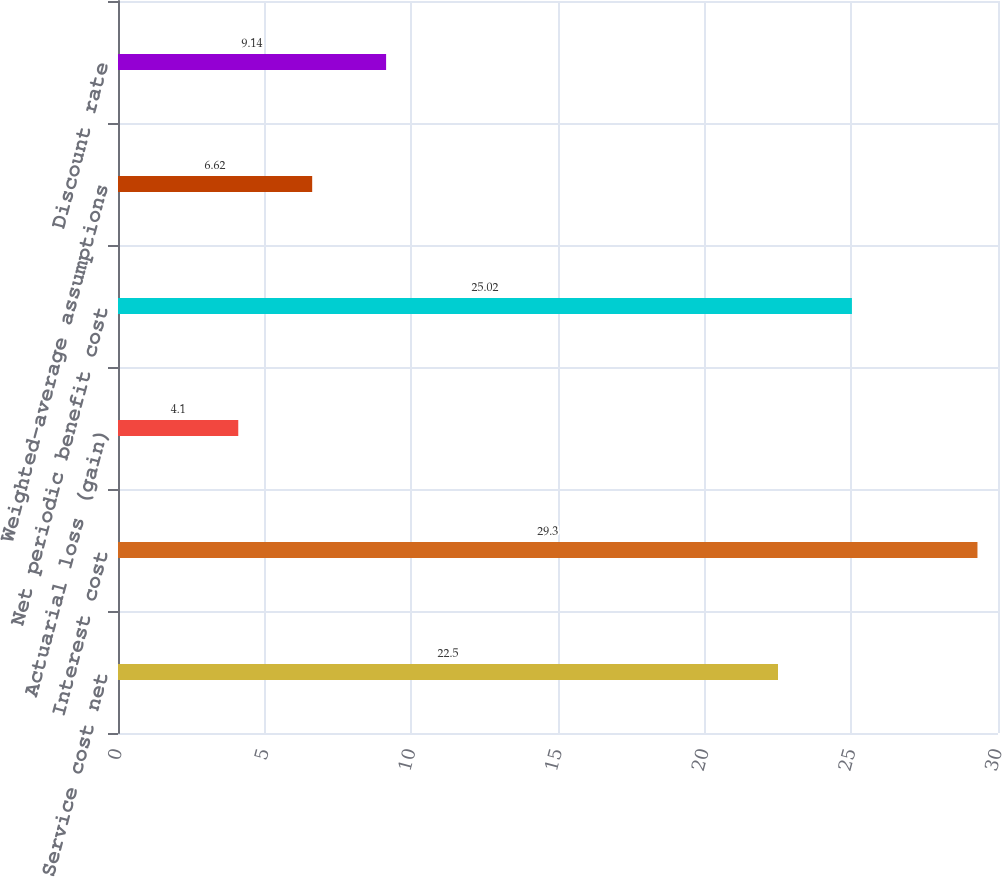<chart> <loc_0><loc_0><loc_500><loc_500><bar_chart><fcel>Service cost net<fcel>Interest cost<fcel>Actuarial loss (gain)<fcel>Net periodic benefit cost<fcel>Weighted-average assumptions<fcel>Discount rate<nl><fcel>22.5<fcel>29.3<fcel>4.1<fcel>25.02<fcel>6.62<fcel>9.14<nl></chart> 